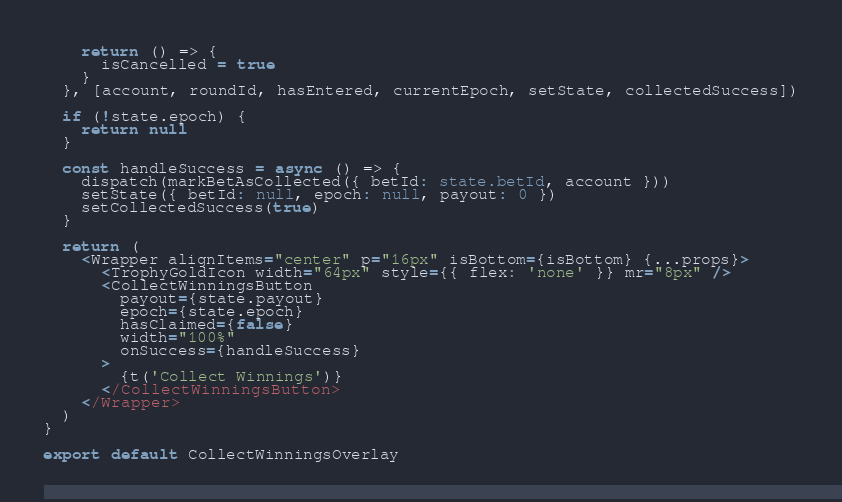Convert code to text. <code><loc_0><loc_0><loc_500><loc_500><_TypeScript_>    return () => {
      isCancelled = true
    }
  }, [account, roundId, hasEntered, currentEpoch, setState, collectedSuccess])

  if (!state.epoch) {
    return null
  }

  const handleSuccess = async () => {
    dispatch(markBetAsCollected({ betId: state.betId, account }))
    setState({ betId: null, epoch: null, payout: 0 })
    setCollectedSuccess(true)
  }

  return (
    <Wrapper alignItems="center" p="16px" isBottom={isBottom} {...props}>
      <TrophyGoldIcon width="64px" style={{ flex: 'none' }} mr="8px" />
      <CollectWinningsButton
        payout={state.payout}
        epoch={state.epoch}
        hasClaimed={false}
        width="100%"
        onSuccess={handleSuccess}
      >
        {t('Collect Winnings')}
      </CollectWinningsButton>
    </Wrapper>
  )
}

export default CollectWinningsOverlay
</code> 